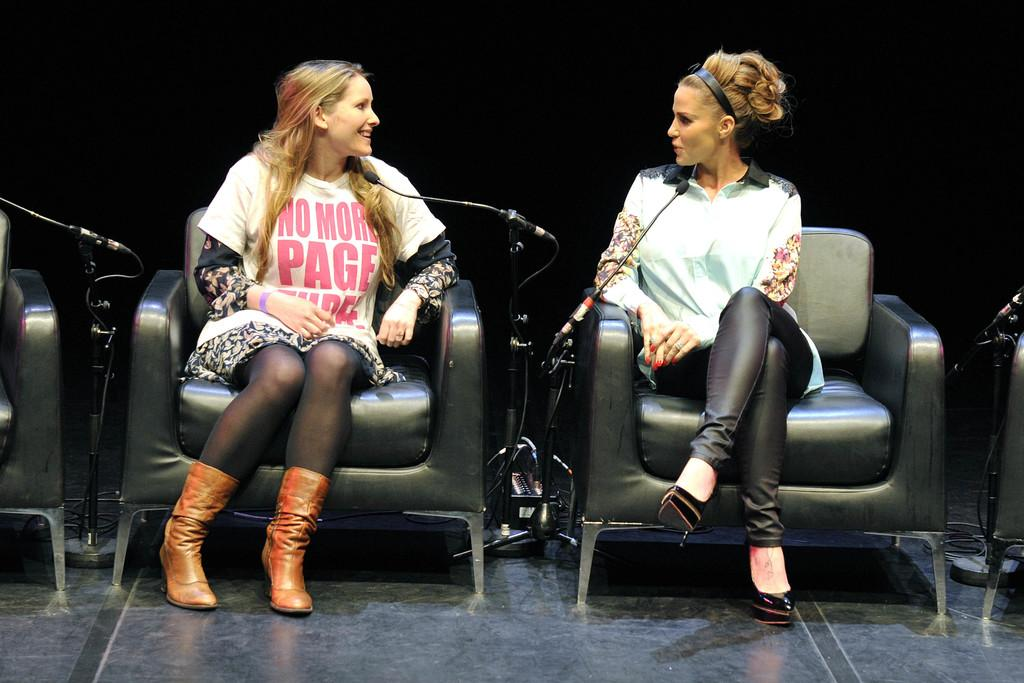What are the people in the image doing? The people in the image are sitting on chairs. What objects are present in the image that are related to speaking or performing? There are mics with stands in the image. How many chairs are visible in the image? There are additional chairs in the image besides the ones the people are sitting on. What part of the room can be seen at the bottom of the image? The floor is visible at the bottom of the image. What type of market is being held in the image? There is no market present in the image; it features people sitting on chairs with mics and additional chairs. Are there any slaves visible in the image? There is no mention of slaves in the image, and the context does not suggest their presence. 